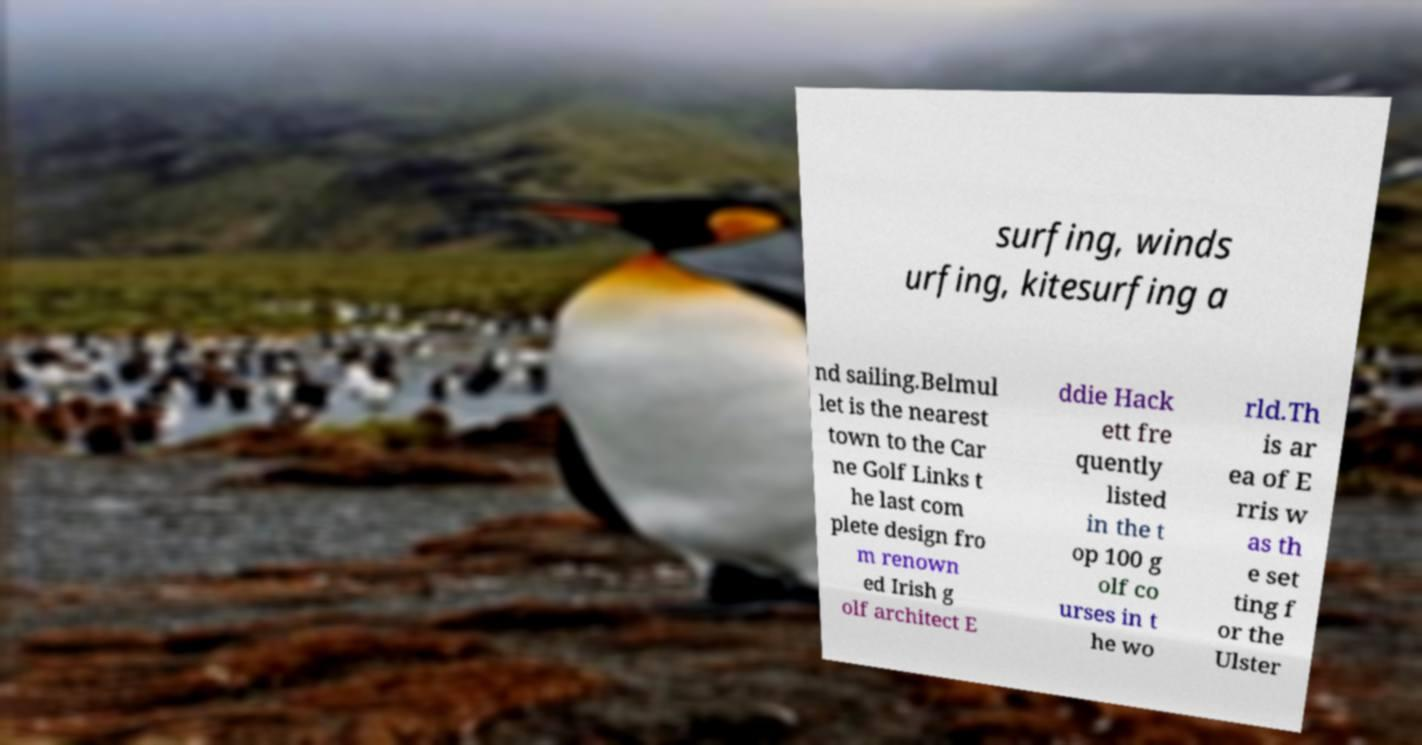Please identify and transcribe the text found in this image. surfing, winds urfing, kitesurfing a nd sailing.Belmul let is the nearest town to the Car ne Golf Links t he last com plete design fro m renown ed Irish g olf architect E ddie Hack ett fre quently listed in the t op 100 g olf co urses in t he wo rld.Th is ar ea of E rris w as th e set ting f or the Ulster 